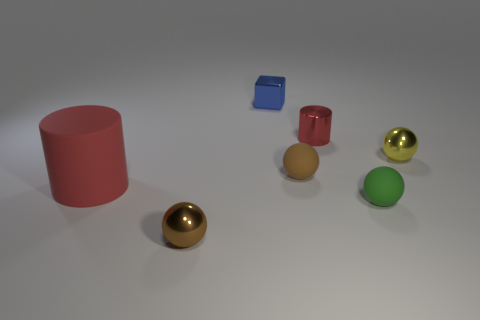There is a object that is the same color as the shiny cylinder; what material is it?
Ensure brevity in your answer.  Rubber. What material is the green thing that is the same size as the red metal thing?
Make the answer very short. Rubber. What number of things are either tiny yellow metallic things or metallic balls?
Provide a succinct answer. 2. What number of metal things are both to the left of the tiny green matte thing and behind the large cylinder?
Keep it short and to the point. 2. Is the number of blue shiny objects that are in front of the red rubber cylinder less than the number of red rubber things?
Your answer should be compact. Yes. What shape is the green thing that is the same size as the brown metallic ball?
Keep it short and to the point. Sphere. What number of other things are there of the same color as the big rubber cylinder?
Your answer should be compact. 1. Do the red rubber cylinder and the blue shiny object have the same size?
Make the answer very short. No. How many objects are big red rubber things or cylinders in front of the brown matte thing?
Your answer should be compact. 1. Are there fewer yellow things behind the metallic block than green rubber things that are behind the large matte thing?
Provide a succinct answer. No. 